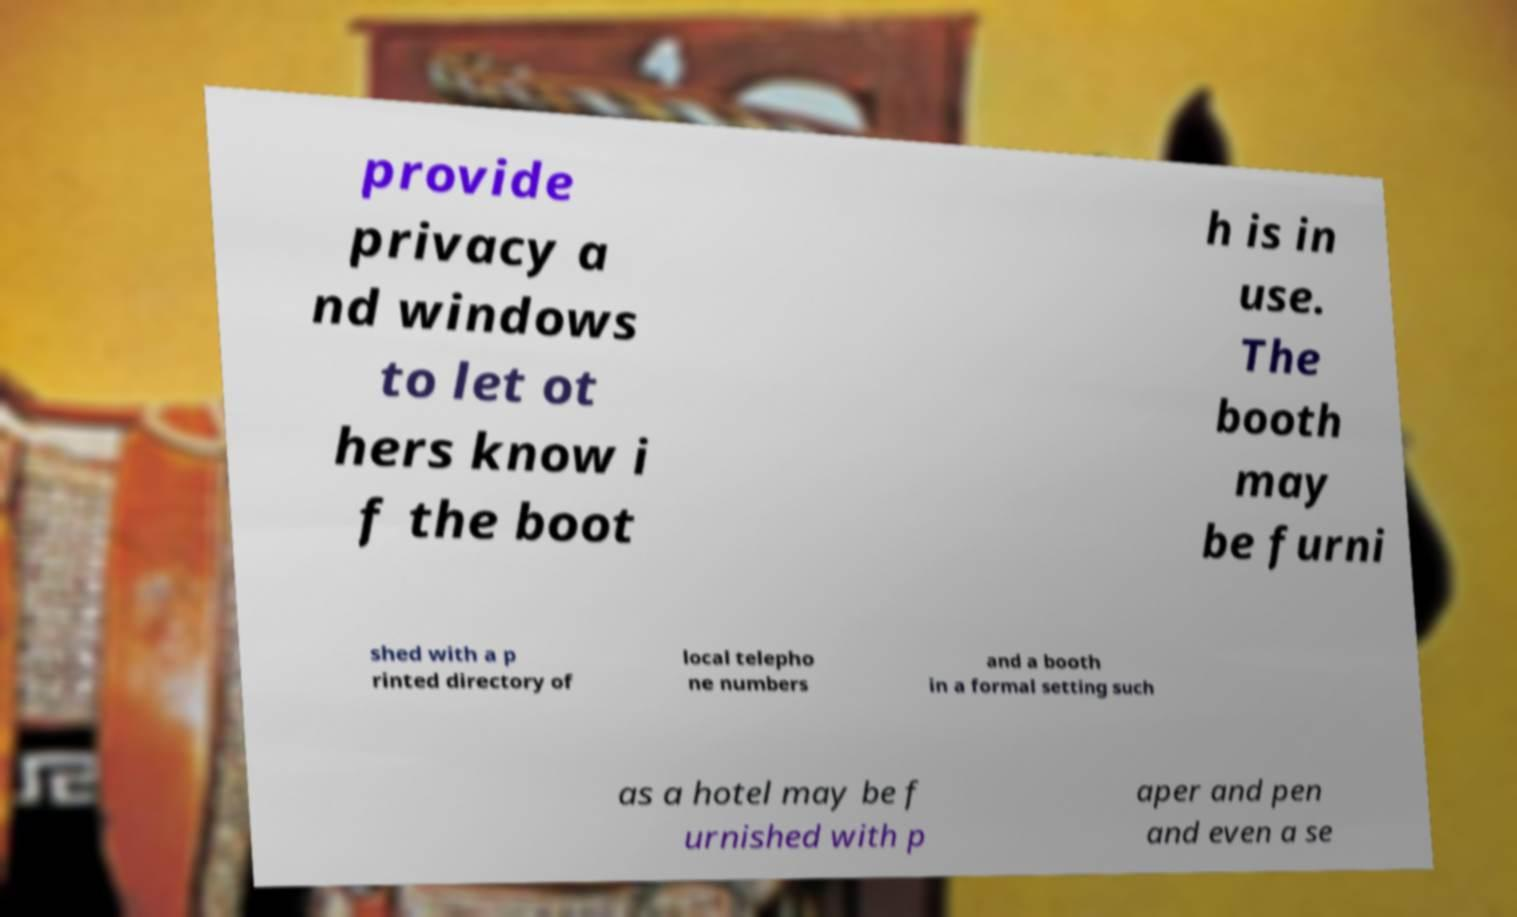There's text embedded in this image that I need extracted. Can you transcribe it verbatim? provide privacy a nd windows to let ot hers know i f the boot h is in use. The booth may be furni shed with a p rinted directory of local telepho ne numbers and a booth in a formal setting such as a hotel may be f urnished with p aper and pen and even a se 